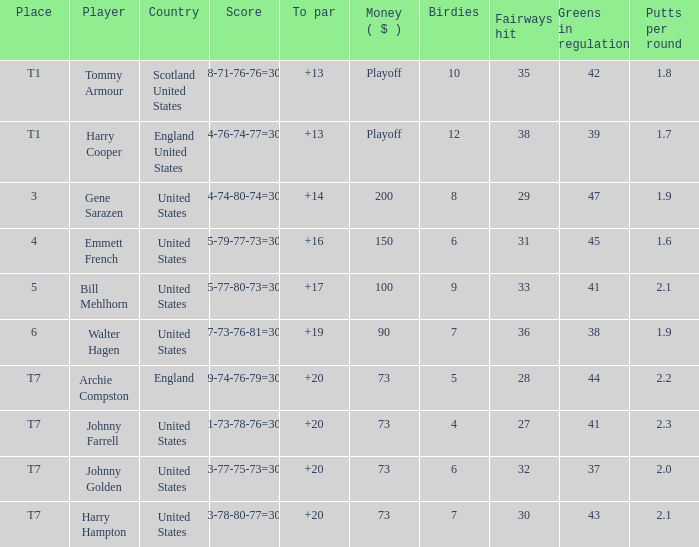What is the score for the United States when Harry Hampton is the player and the money is $73? 73-78-80-77=308. 